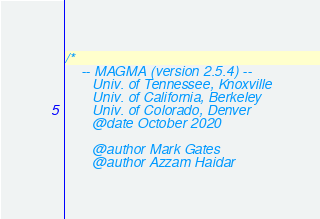<code> <loc_0><loc_0><loc_500><loc_500><_Cuda_>/*
    -- MAGMA (version 2.5.4) --
       Univ. of Tennessee, Knoxville
       Univ. of California, Berkeley
       Univ. of Colorado, Denver
       @date October 2020

       @author Mark Gates
       @author Azzam Haidar
</code> 